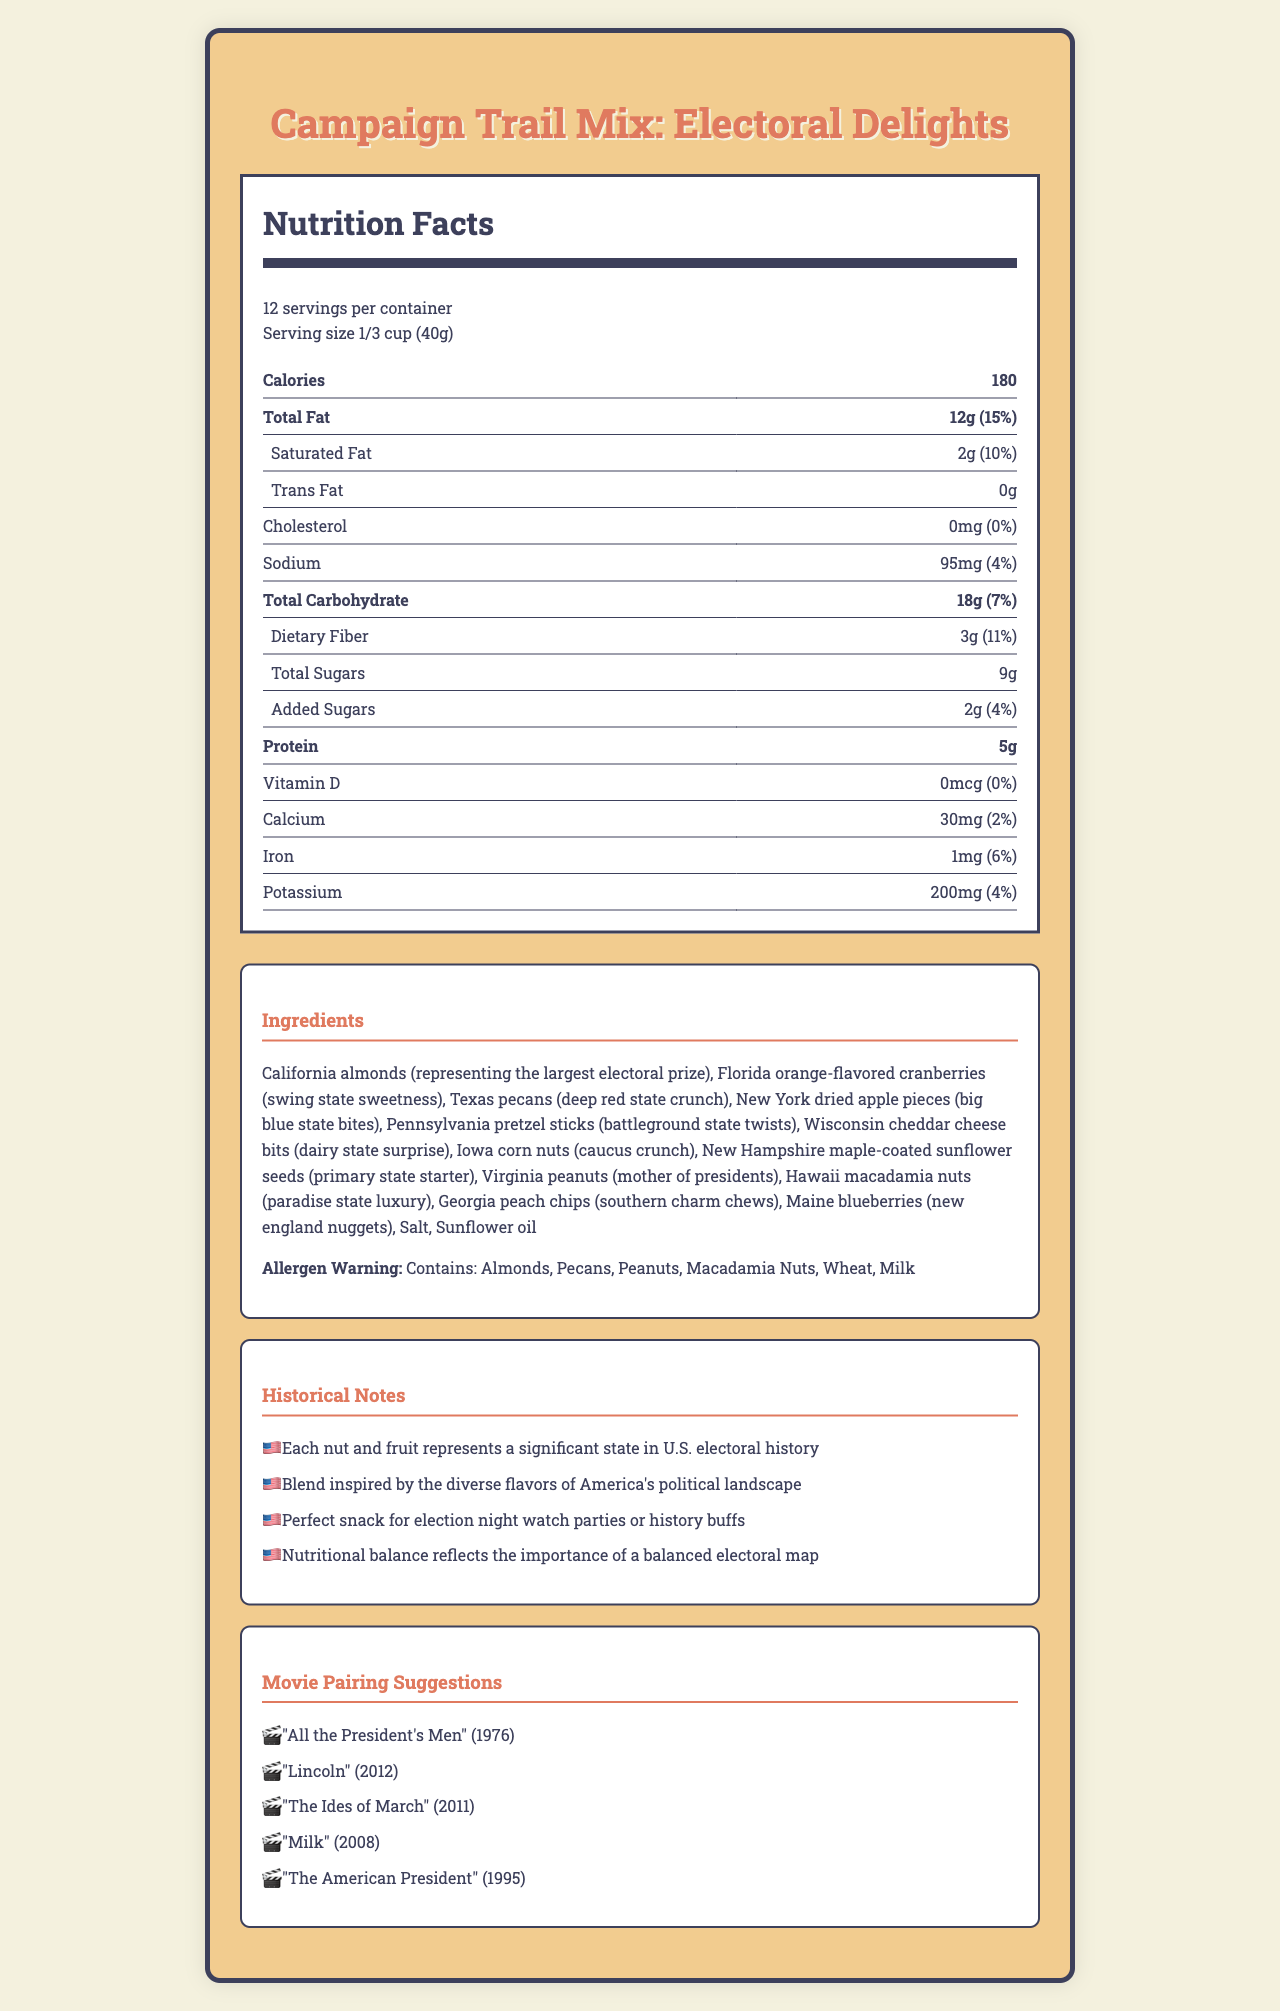what is the serving size? The serving size is clearly stated in the Nutrition Facts section of the document as "1/3 cup (40g)".
Answer: 1/3 cup (40g) how many calories are in one serving? The document specifies that there are 180 calories per serving in the Nutrition Facts section.
Answer: 180 how much sodium does one serving contain? According to the Nutrition Facts section, one serving contains 95mg of sodium.
Answer: 95mg what allergens are present in the Campaign Trail Mix? The allergen warning section lists these specific allergens.
Answer: Almonds, Pecans, Peanuts, Macadamia Nuts, Wheat, Milk which nut represents California? The Ingredients section states that "California almonds" represent the largest electoral prize.
Answer: Almonds how many servings are in the entire container? The Nutrition Facts section indicates that there are 12 servings per container.
Answer: 12 what percentage of daily value is the total fat content per serving? The Nutrition Facts section specifies that the total fat content per serving is 15% of the daily value.
Answer: 15% how much protein is in one serving? The document lists the protein content per serving as 5g in the Nutrition Facts section.
Answer: 5g how much iron is in one serving? The Nutrition Facts section lists iron content as 1mg per serving.
Answer: 1mg what fruits represent Florida and New York, respectively? According to the Ingredients section, Florida is represented by orange-flavored cranberries and New York by dried apple pieces.
Answer: Orange-flavored cranberries and dried apple pieces which of the following states is represented by pecans? A. California B. Texas C. Iowa The Ingredients section indicates that Texas is represented by pecans.
Answer: B how much dietary fiber is in one serving? A. 2g B. 3g C. 4g D. 5g The Nutrition Facts section mentions that there are 3g of dietary fiber per serving.
Answer: B is there any cholesterol in the Campaign Trail Mix? Yes/No The Nutrition Facts section states that the cholesterol amount is 0mg (0%).
Answer: No summarize the main purpose of the document. The main sections of the document include the nutritional facts, a list of ingredients along with an allergen warning, historical notes about the representation of states, and movie pairing suggestions.
Answer: The document provides detailed nutritional information, ingredients, historical notes, and movie pairing suggestions for the Campaign Trail Mix: Electoral Delights, a snack that combines various nuts and dried fruits representing different significant states in U.S. electoral history. what is the total amount of fat in two servings? One serving has 12g of total fat. Multiplying this by two yields 24g.
Answer: 24g what is the historical significance of the Campaign Trail Mix? The Historical Notes section explains how each nut and fruit in the mix represents a significant state in U.S. electoral history, reflecting America's diverse political landscape.
Answer: It blends ingredients representing significant states in U.S. electoral history. what movie pairs well with the Trail Mix and is about a U.S. president's life? The Movie Pairing Suggestions section recommends "Lincoln" (2012), a film about President Abraham Lincoln's life.
Answer: "Lincoln" (2012) what is the level of vitamin D in one serving? The Nutrition Facts section states that the vitamin D content per serving is 0mcg.
Answer: 0mcg what inspired the blend of ingredients in the Campaign Trail Mix? The Historical Notes section mentions that the blend is inspired by the diverse flavors of America's political landscape.
Answer: The diverse flavors of America's political landscape. what electoral significance does Georgia represent in the Trail Mix? The Ingredients section states that Georgia is represented by peach chips, referred to as "southern charm chews".
Answer: Southern charm chews. how many grams of added sugars are in one serving? According to the Nutrition Facts section, one serving contains 2g of added sugars.
Answer: 2g which ingredient provides the "big blue state bites"? The Ingredients section states that New York is represented by dried apple pieces, referred to as "big blue state bites".
Answer: New York dried apple pieces what movie recommendation was made for 1976? The Movie Pairing Suggestions section lists "All the President's Men" (1976) as a recommendation.
Answer: "All the President's Men" is the document specifically linked to any political campaign? The document does not provide any specific link to a political campaign; it simply uses electoral themes and states as representations.
Answer: Not enough information 